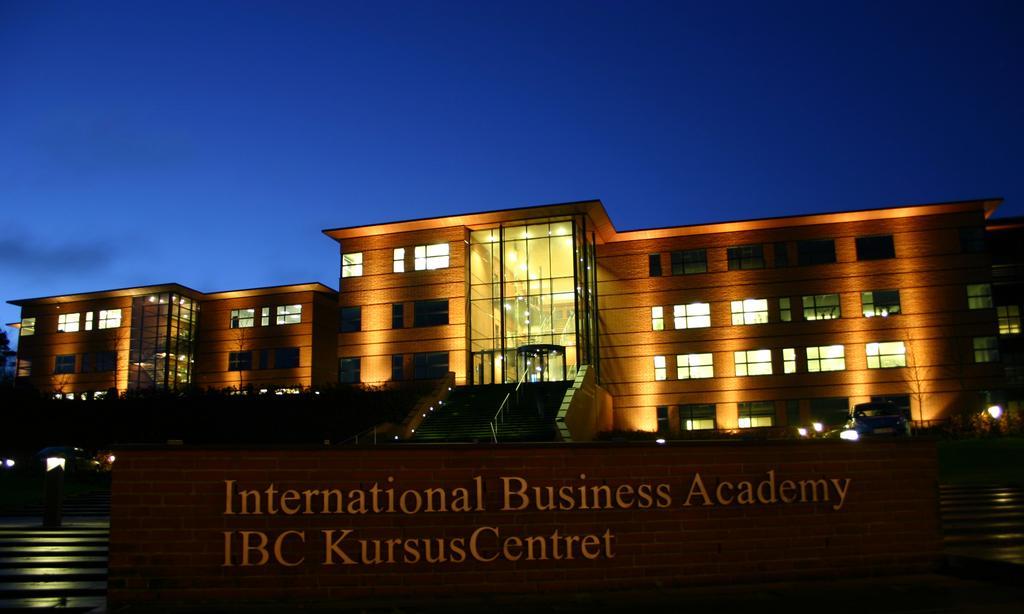Can you describe this image briefly? In this image there are few buildings. Before it there is a staircase. Beside it there are few trees. Bottom of the image there is some text. Top of the image there is sky. Right side there is a vehicle. Right bottom there are few stairs. 